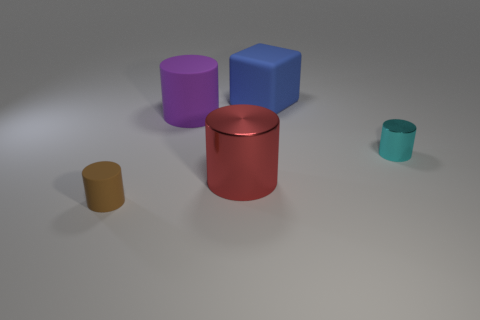Is there anything else that has the same shape as the blue rubber thing?
Make the answer very short. No. What size is the thing to the left of the large purple thing to the right of the brown matte thing?
Make the answer very short. Small. What shape is the big red shiny object?
Your answer should be compact. Cylinder. What number of big things are gray metallic cubes or red shiny cylinders?
Offer a very short reply. 1. The cyan shiny thing that is the same shape as the purple object is what size?
Your response must be concise. Small. What number of objects are behind the tiny rubber thing and left of the blue thing?
Make the answer very short. 2. Is the shape of the big red thing the same as the small object that is to the right of the matte block?
Give a very brief answer. Yes. Are there more big rubber things that are right of the big blue rubber cube than tiny cyan rubber balls?
Ensure brevity in your answer.  No. Is the number of purple cylinders that are to the left of the tiny rubber cylinder less than the number of brown things?
Your response must be concise. Yes. How many big metallic cylinders are the same color as the large rubber cylinder?
Provide a succinct answer. 0. 